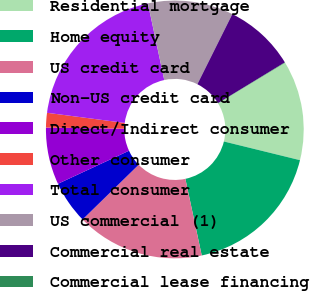<chart> <loc_0><loc_0><loc_500><loc_500><pie_chart><fcel>Residential mortgage<fcel>Home equity<fcel>US credit card<fcel>Non-US credit card<fcel>Direct/Indirect consumer<fcel>Other consumer<fcel>Total consumer<fcel>US commercial (1)<fcel>Commercial real estate<fcel>Commercial lease financing<nl><fcel>12.49%<fcel>17.82%<fcel>16.04%<fcel>5.38%<fcel>7.16%<fcel>1.83%<fcel>19.59%<fcel>10.71%<fcel>8.93%<fcel>0.05%<nl></chart> 